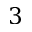Convert formula to latex. <formula><loc_0><loc_0><loc_500><loc_500>3</formula> 